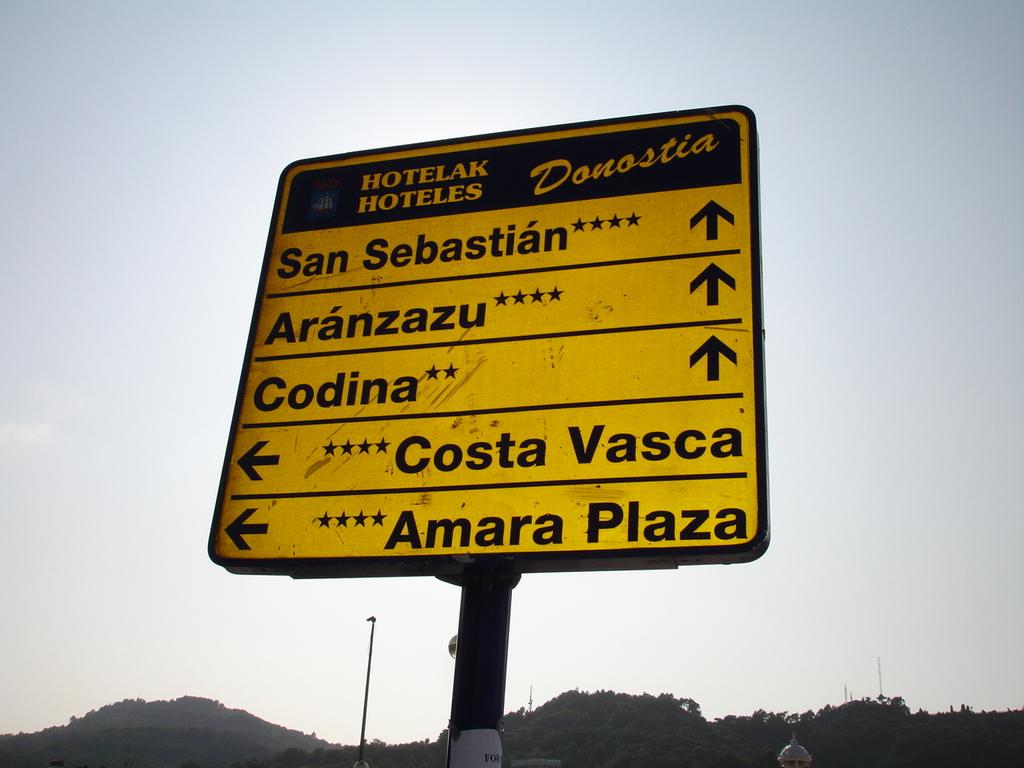What is the first destination to the left?
Your response must be concise. Costa vasca. What is the first location going straight?
Ensure brevity in your answer.  San sebastian. 